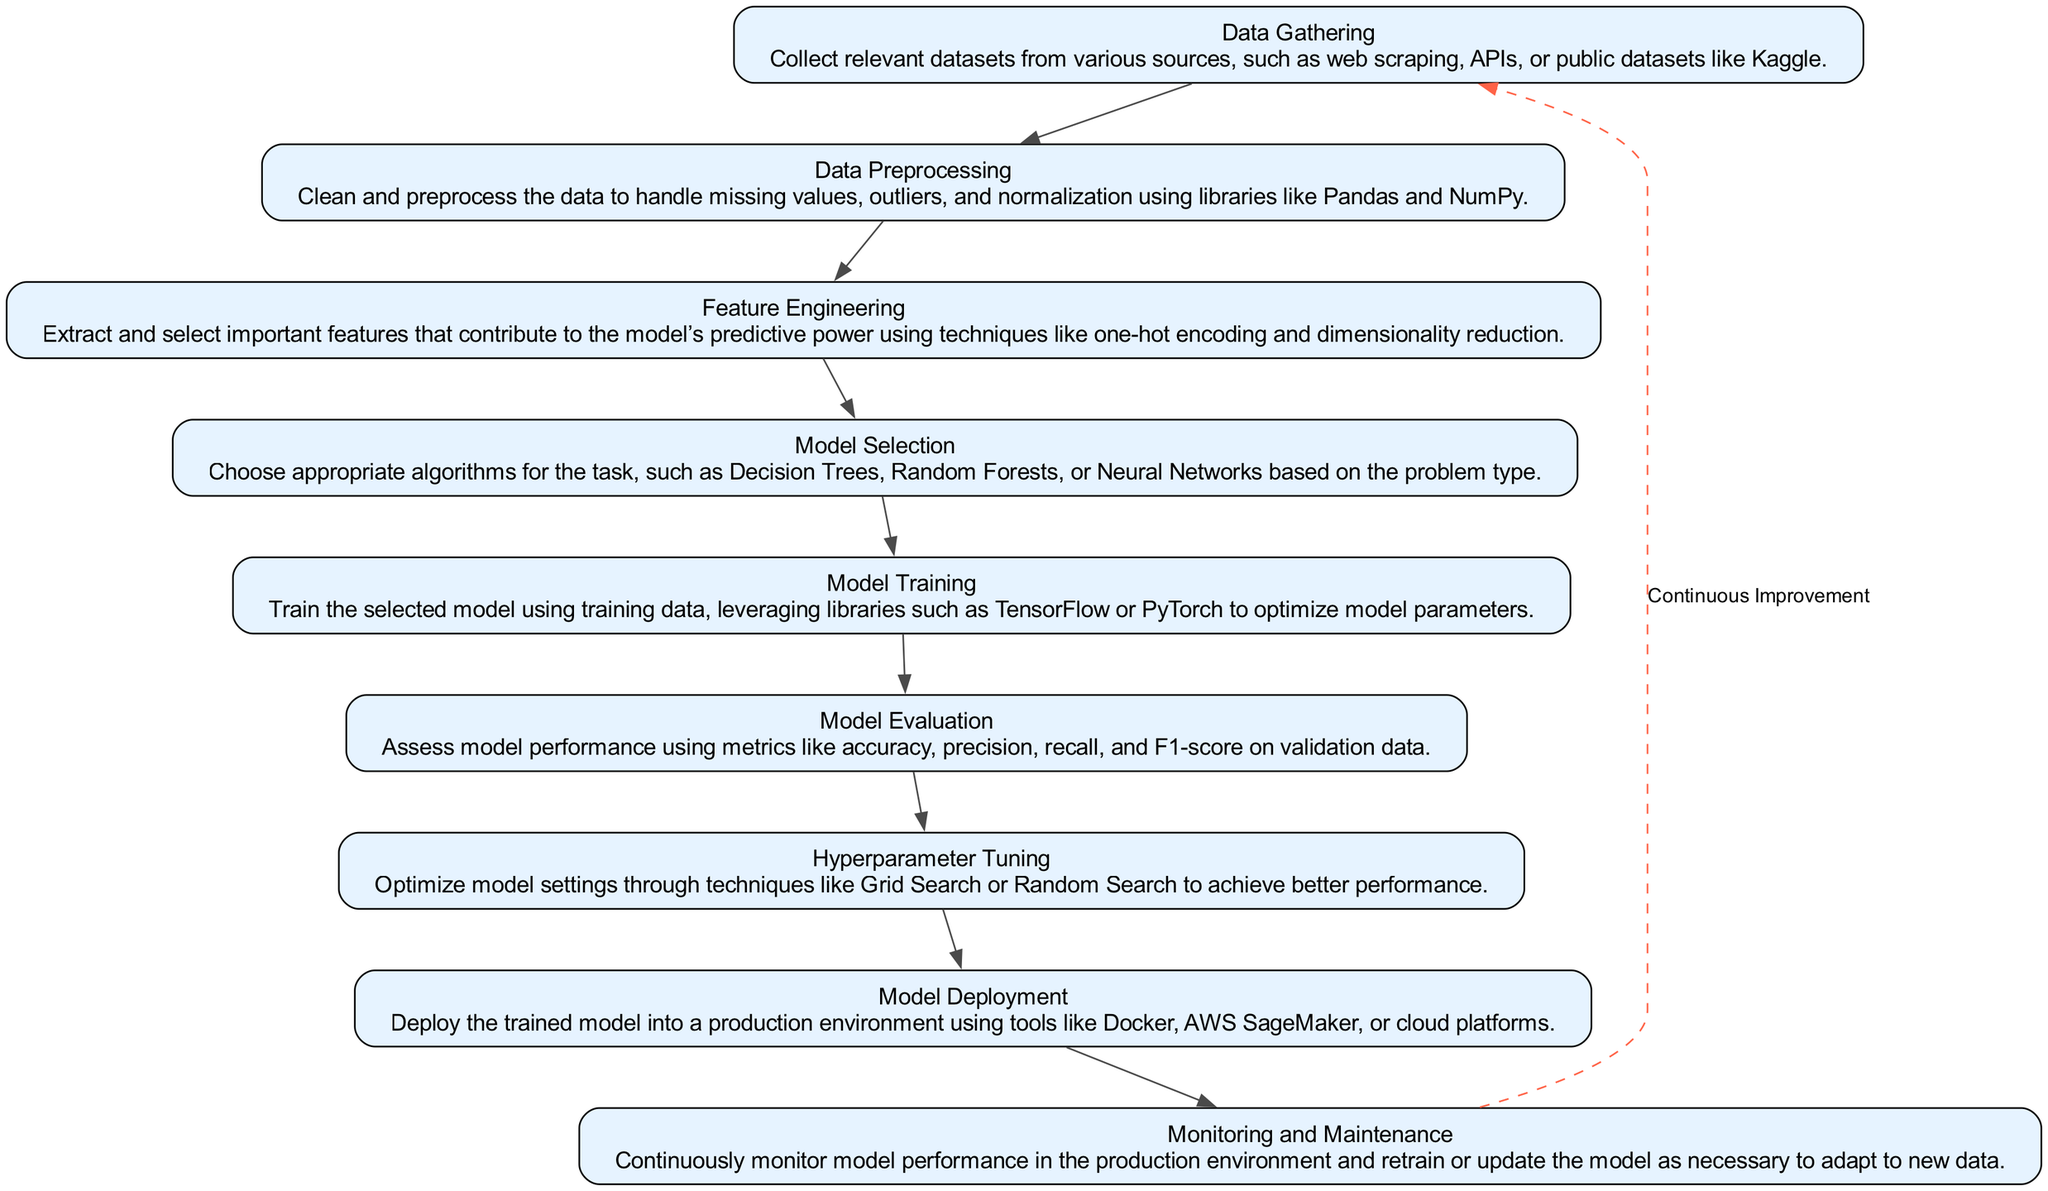What is the first stage of the AI model development lifecycle? The diagram outlines multiple stages in the AI model development lifecycle. The first stage is prominently listed at the top and is named "Data Gathering."
Answer: Data Gathering How many stages are there in total? By counting each individual stage represented in the diagram, we find that there are nine distinct stages in the AI model development lifecycle.
Answer: Nine What is the main action in the "Model Evaluation" stage? The description provided in the diagram for the "Model Evaluation" stage highlights assessing model performance, particularly focusing on evaluating various performance metrics.
Answer: Assess model performance Which stage follows "Feature Engineering"? The flowchart displays a directional flow from one stage to the next. Following the "Feature Engineering" stage, the immediate next stage is "Model Selection."
Answer: Model Selection What is the purpose of Hyperparameter Tuning? The diagram describes Hyperparameter Tuning as a process aimed at optimizing model settings using specified techniques to enhance performance, indicating its crucial role in model refinement.
Answer: Optimize model settings What connects the last stage to the first stage? Notably, there is a dashed edge labeled "Continuous Improvement" that flows back from the last stage, "Monitoring and Maintenance," to the first stage, which emphasizes the iterative nature of the lifecycle.
Answer: Continuous Improvement Which library is mentioned for training models? The mention of applicable libraries occurs in the "Model Training" stage, where both TensorFlow and PyTorch are specified as the tools suitable for training models.
Answer: TensorFlow and PyTorch What stage assesses accuracy, precision, recall, and F1-score? The stage that specifically focuses on the evaluation of these key performance metrics is the "Model Evaluation" stage, highlighting its significance in model assessment.
Answer: Model Evaluation 